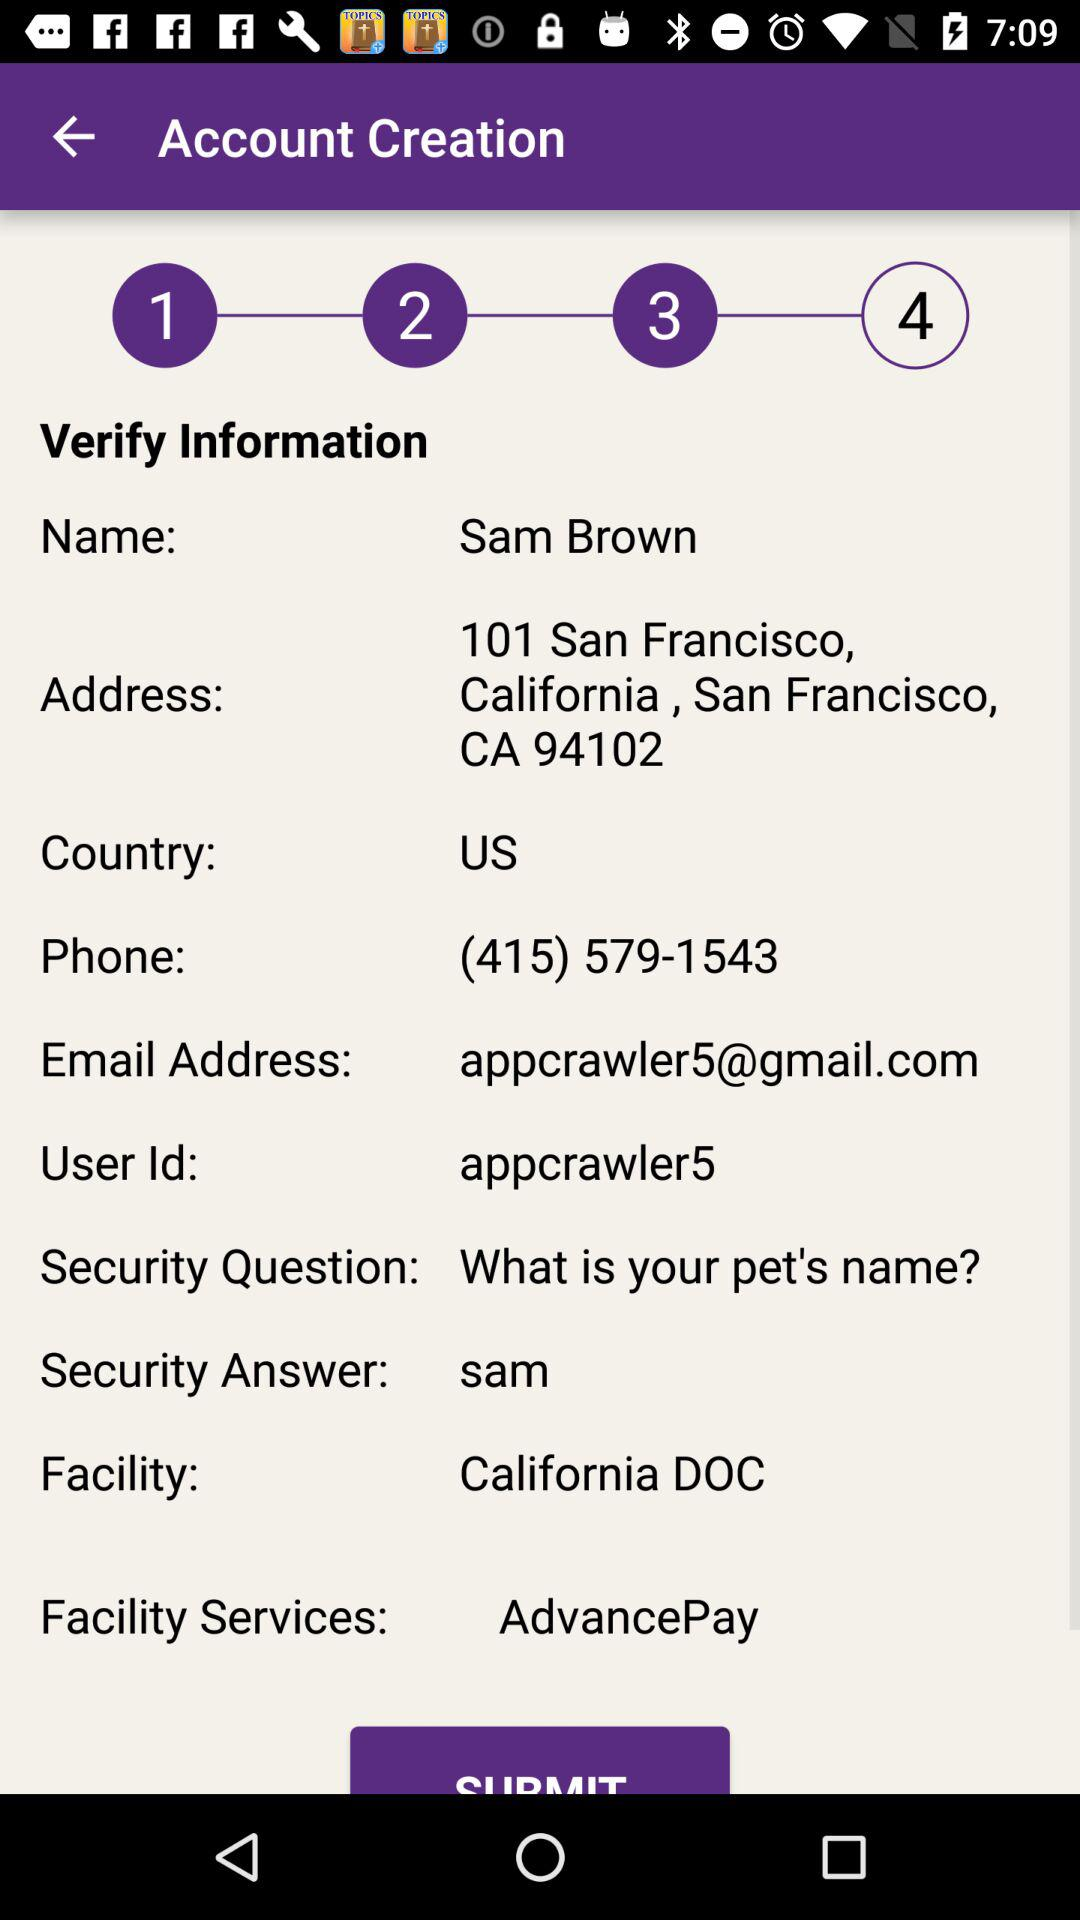What is the phone number? The phone number is (415) 579-1543. 